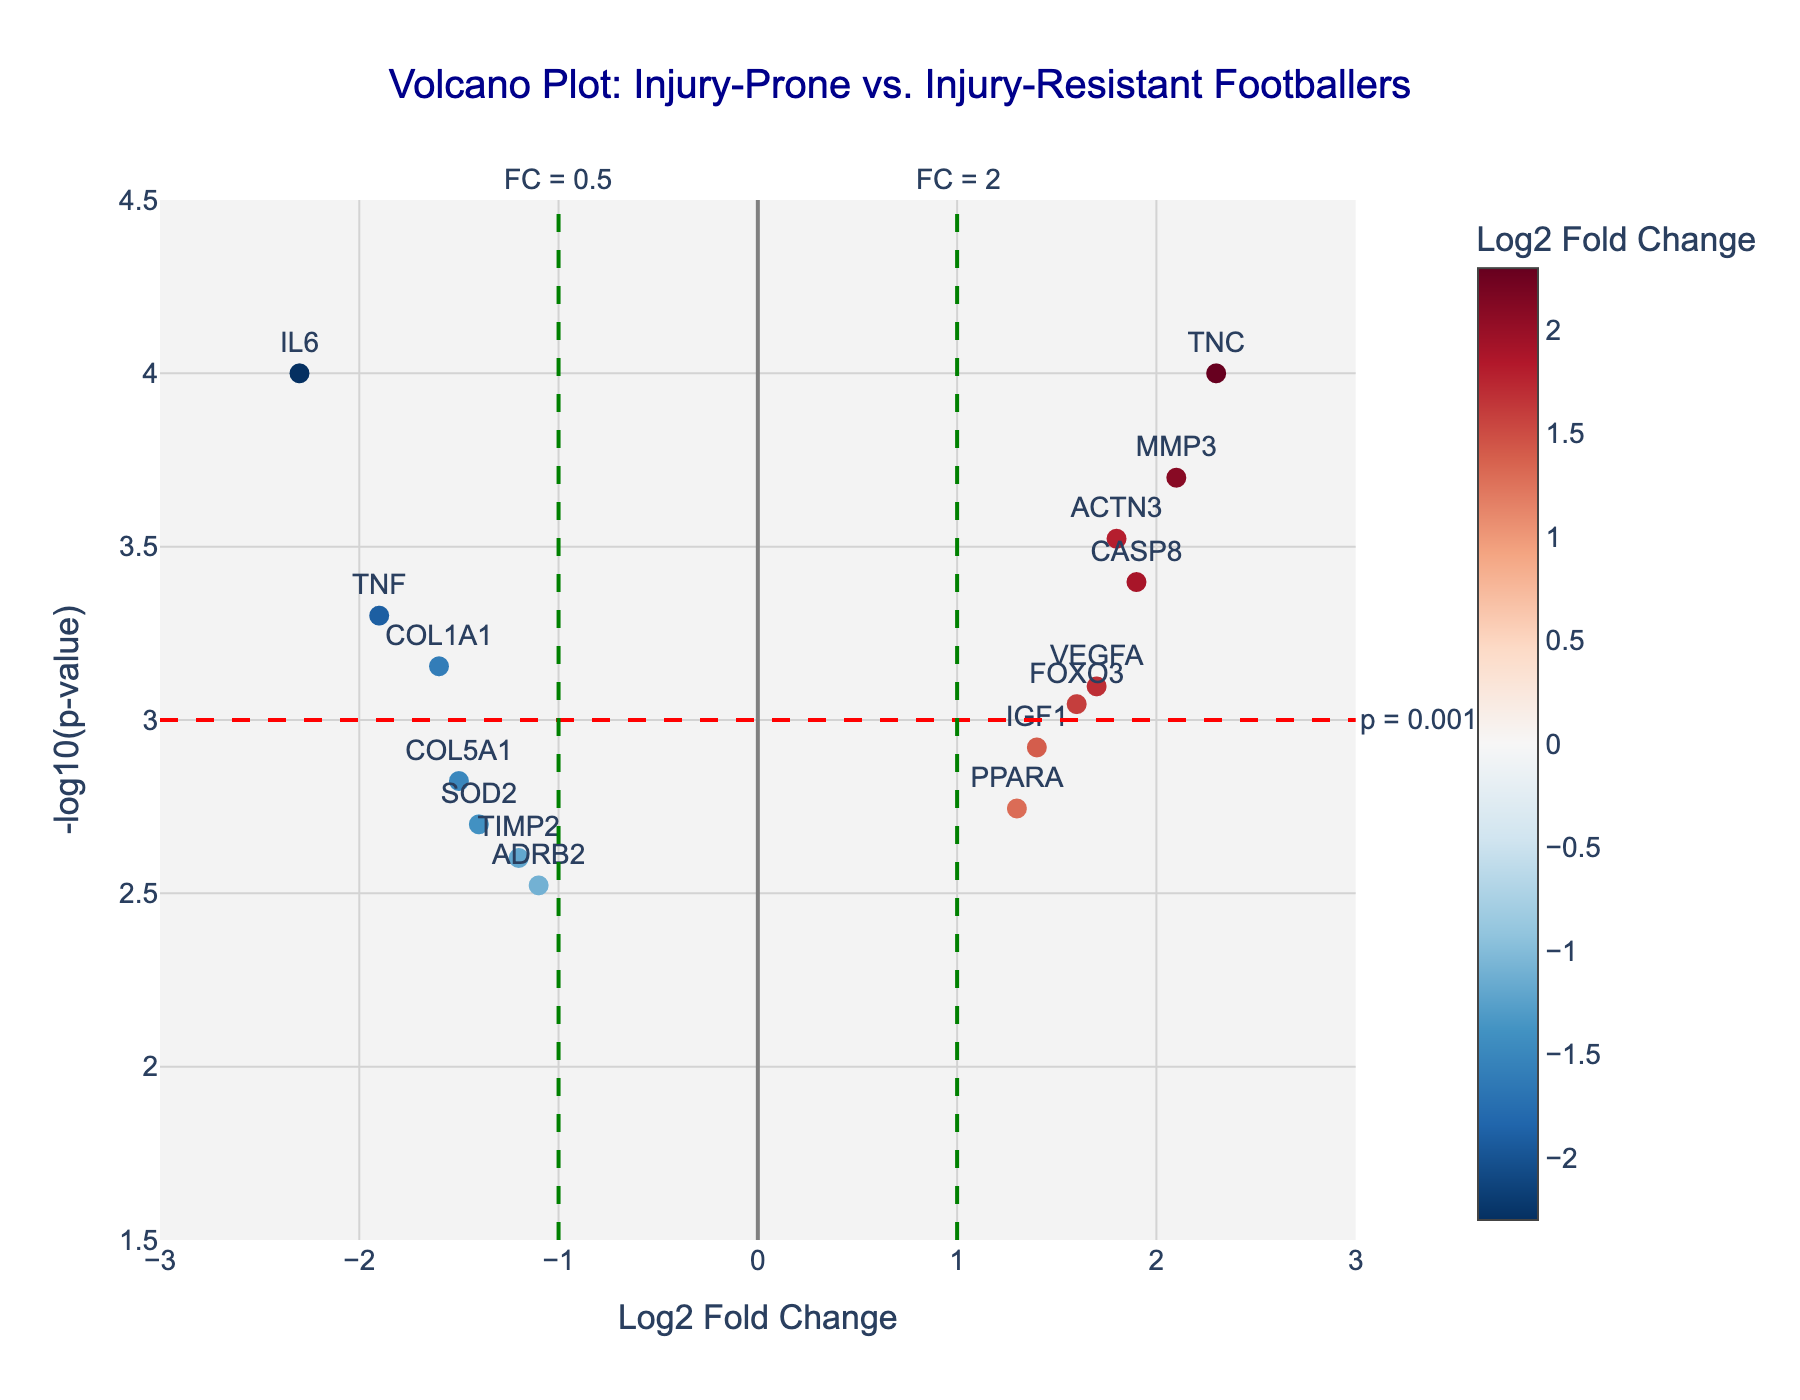How many genes are labeled on the volcano plot? Count the number of unique gene labels on the figure. There are 15 genes listed in the data that are labeled.
Answer: 15 What is the title of the plot? Look at the top of the figure to read the title. The title clearly states: "Volcano Plot: Injury-Prone vs. Injury-Resistant Footballers".
Answer: Volcano Plot: Injury-Prone vs. Injury-Resistant Footballers What is the range of the Log2 Fold Change axis? Analyze the x-axis range from the ticks. The x-axis ranges from -3 to 3.
Answer: -3 to 3 Which gene has the highest fold change? Look along the x-axis for the gene with the highest positive Log2 Fold Change value. `TNC` has the highest Log2 Fold Change at 2.3.
Answer: TNC Which gene has the most significant p-value? Check the y-axis for the highest -log10(p-value). This corresponds to the smallest p-value. `IL6` and `TNC` have the highest -log10(p-value) with a value of 4.
Answer: IL6 and TNC Which genes are overexpressed (Log2FC > 0) and have highly significant p-values (p < 0.001)? Look at the right side of the plot where Log2 Fold Change is greater than 0 and above the horizontal dashed line representing p = 0.001. `ACTN3`, `MMP3`, `TNC`, and `CASP8` meet these criteria.
Answer: ACTN3, MMP3, TNC, and CASP8 Which gene has a Log2 Fold Change closest to zero? Look near the center of the x-axis and identify the gene with the value closest to zero. `ADRB2`, `TIMP2`, and `PPAARA` have Log2 Fold Changes close to zero, with `ADRB2` being the closest at 1.1.
Answer: ADRB2 How many genes have a Log2 Fold Change greater than 1.5? Count the genes positioned to the right of a Log2 Fold Change of 1.5 on the x-axis. There are 6 genes: `ACTN3`, `MMP3`, `VEGFA`, `TNC`, `CASP8`, and `FOXO3`.
Answer: 6 Compare the Log2 Fold Change of `TNF` and `VEGFA`. Which one is higher? Check the x-axis positions for the Log2 Fold Change values of `TNF` and `VEGFA`. `VEGFA` has a Log2 Fold Change of 1.7, which is higher than `TNF`'s -1.9.
Answer: VEGFA What p-value threshold is indicated by the horizontal dashed line? Observe the horizontal dashed line's annotation on the right side of the plot. The line indicates a p-value threshold of 0.001.
Answer: 0.001 